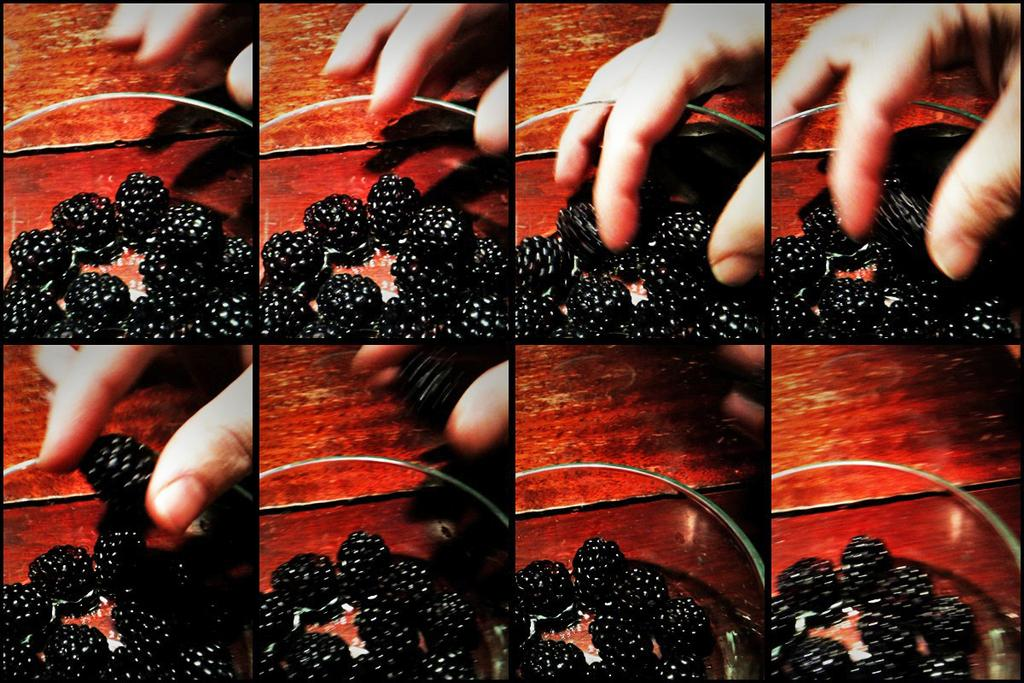What is the main subject of the image? There is a person in the image. What is the person holding in the image? The person is holding berries. How are the berries arranged in the image? The berries are placed in a bowl. What type of calculator is the person using to count the berries in the image? There is no calculator present in the image, and the person is not counting the berries. 